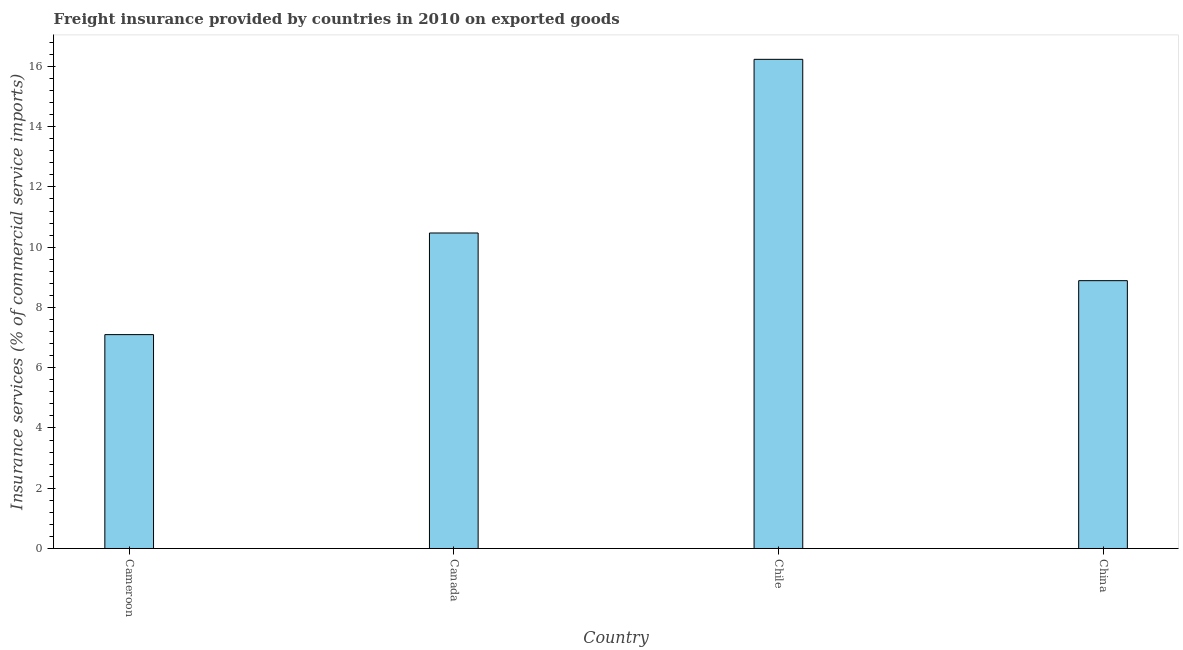Does the graph contain grids?
Your answer should be compact. No. What is the title of the graph?
Offer a very short reply. Freight insurance provided by countries in 2010 on exported goods . What is the label or title of the Y-axis?
Your response must be concise. Insurance services (% of commercial service imports). What is the freight insurance in China?
Provide a succinct answer. 8.89. Across all countries, what is the maximum freight insurance?
Give a very brief answer. 16.23. Across all countries, what is the minimum freight insurance?
Make the answer very short. 7.1. In which country was the freight insurance maximum?
Your answer should be very brief. Chile. In which country was the freight insurance minimum?
Your answer should be compact. Cameroon. What is the sum of the freight insurance?
Your answer should be very brief. 42.69. What is the difference between the freight insurance in Canada and Chile?
Offer a terse response. -5.76. What is the average freight insurance per country?
Give a very brief answer. 10.67. What is the median freight insurance?
Offer a very short reply. 9.68. What is the ratio of the freight insurance in Cameroon to that in Canada?
Ensure brevity in your answer.  0.68. Is the difference between the freight insurance in Cameroon and China greater than the difference between any two countries?
Keep it short and to the point. No. What is the difference between the highest and the second highest freight insurance?
Keep it short and to the point. 5.76. Is the sum of the freight insurance in Canada and China greater than the maximum freight insurance across all countries?
Ensure brevity in your answer.  Yes. What is the difference between the highest and the lowest freight insurance?
Offer a terse response. 9.14. How many bars are there?
Your answer should be compact. 4. Are all the bars in the graph horizontal?
Your answer should be compact. No. How many countries are there in the graph?
Offer a terse response. 4. What is the difference between two consecutive major ticks on the Y-axis?
Your response must be concise. 2. What is the Insurance services (% of commercial service imports) of Cameroon?
Your answer should be very brief. 7.1. What is the Insurance services (% of commercial service imports) of Canada?
Ensure brevity in your answer.  10.47. What is the Insurance services (% of commercial service imports) of Chile?
Make the answer very short. 16.23. What is the Insurance services (% of commercial service imports) in China?
Give a very brief answer. 8.89. What is the difference between the Insurance services (% of commercial service imports) in Cameroon and Canada?
Your answer should be compact. -3.37. What is the difference between the Insurance services (% of commercial service imports) in Cameroon and Chile?
Provide a short and direct response. -9.14. What is the difference between the Insurance services (% of commercial service imports) in Cameroon and China?
Provide a succinct answer. -1.79. What is the difference between the Insurance services (% of commercial service imports) in Canada and Chile?
Your answer should be compact. -5.76. What is the difference between the Insurance services (% of commercial service imports) in Canada and China?
Provide a succinct answer. 1.58. What is the difference between the Insurance services (% of commercial service imports) in Chile and China?
Provide a succinct answer. 7.35. What is the ratio of the Insurance services (% of commercial service imports) in Cameroon to that in Canada?
Ensure brevity in your answer.  0.68. What is the ratio of the Insurance services (% of commercial service imports) in Cameroon to that in Chile?
Your response must be concise. 0.44. What is the ratio of the Insurance services (% of commercial service imports) in Cameroon to that in China?
Provide a short and direct response. 0.8. What is the ratio of the Insurance services (% of commercial service imports) in Canada to that in Chile?
Your answer should be compact. 0.65. What is the ratio of the Insurance services (% of commercial service imports) in Canada to that in China?
Give a very brief answer. 1.18. What is the ratio of the Insurance services (% of commercial service imports) in Chile to that in China?
Your answer should be compact. 1.83. 